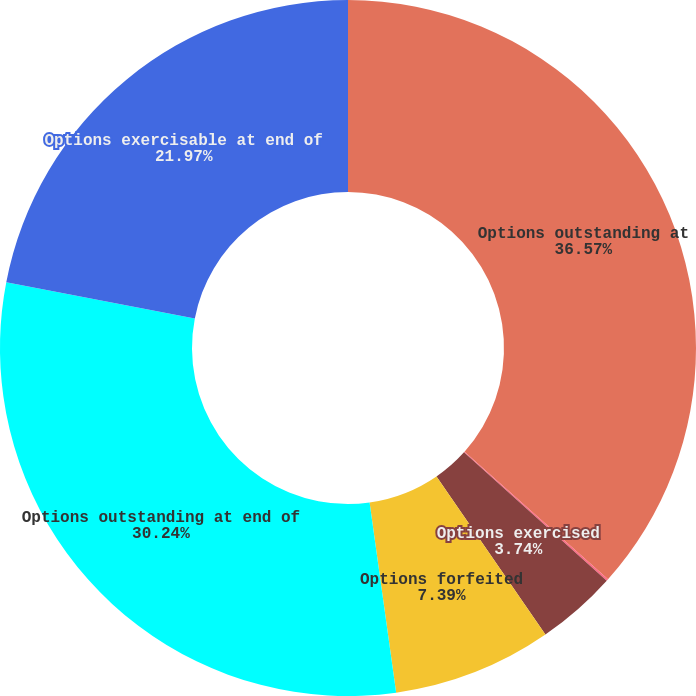<chart> <loc_0><loc_0><loc_500><loc_500><pie_chart><fcel>Options outstanding at<fcel>Options granted<fcel>Options exercised<fcel>Options forfeited<fcel>Options outstanding at end of<fcel>Options exercisable at end of<nl><fcel>36.57%<fcel>0.09%<fcel>3.74%<fcel>7.39%<fcel>30.24%<fcel>21.97%<nl></chart> 